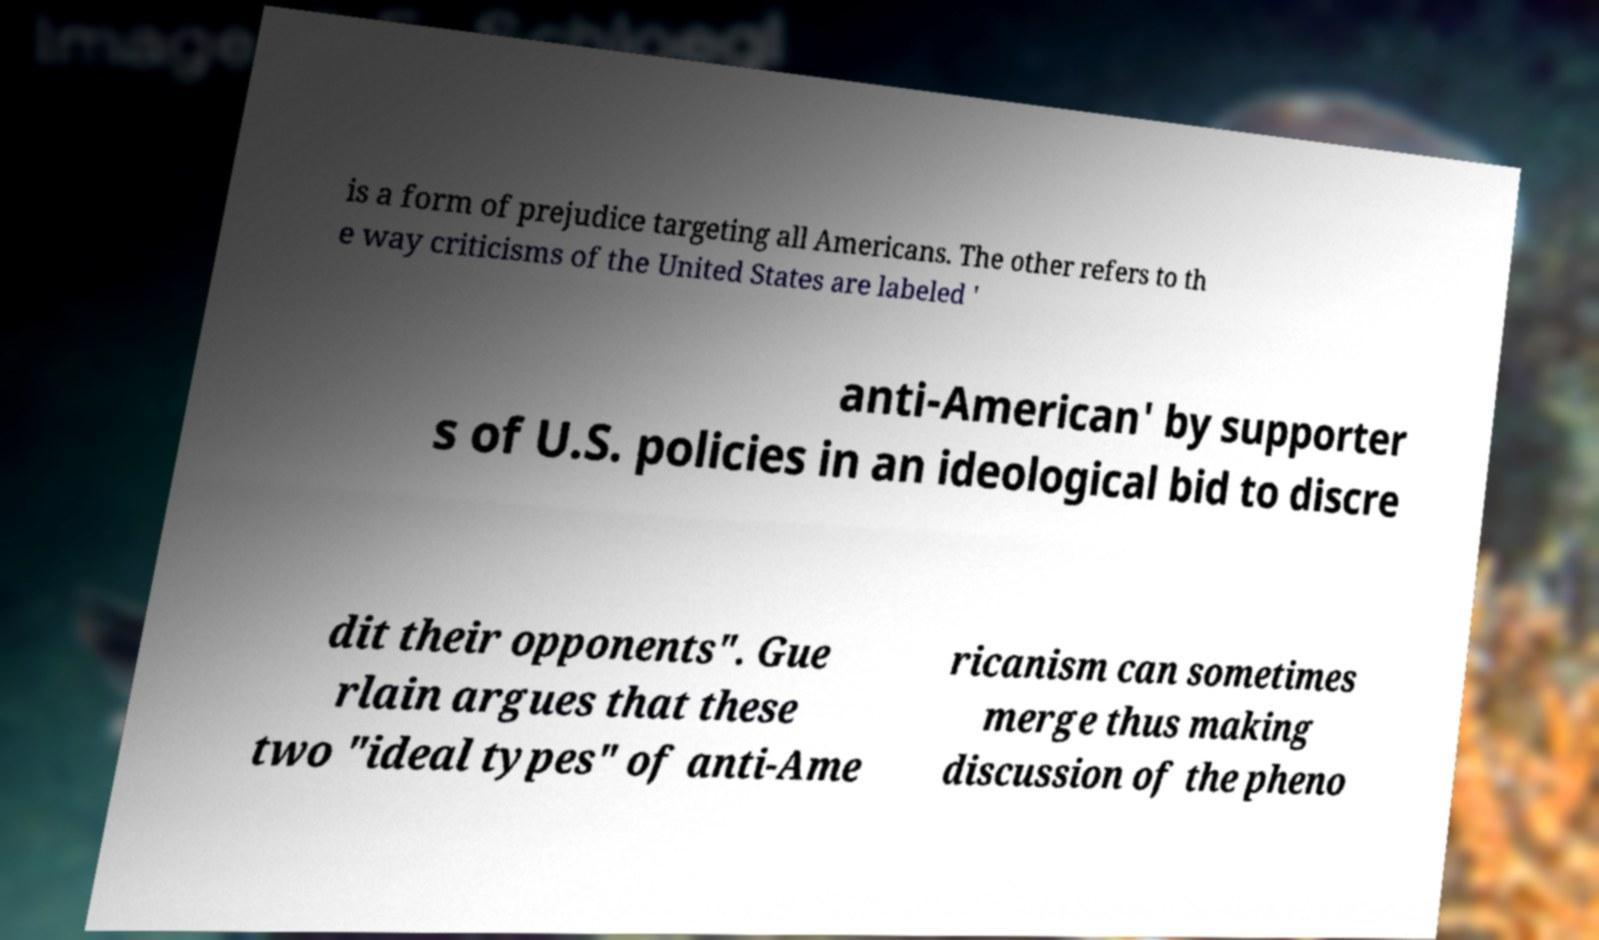I need the written content from this picture converted into text. Can you do that? is a form of prejudice targeting all Americans. The other refers to th e way criticisms of the United States are labeled ' anti-American' by supporter s of U.S. policies in an ideological bid to discre dit their opponents". Gue rlain argues that these two "ideal types" of anti-Ame ricanism can sometimes merge thus making discussion of the pheno 